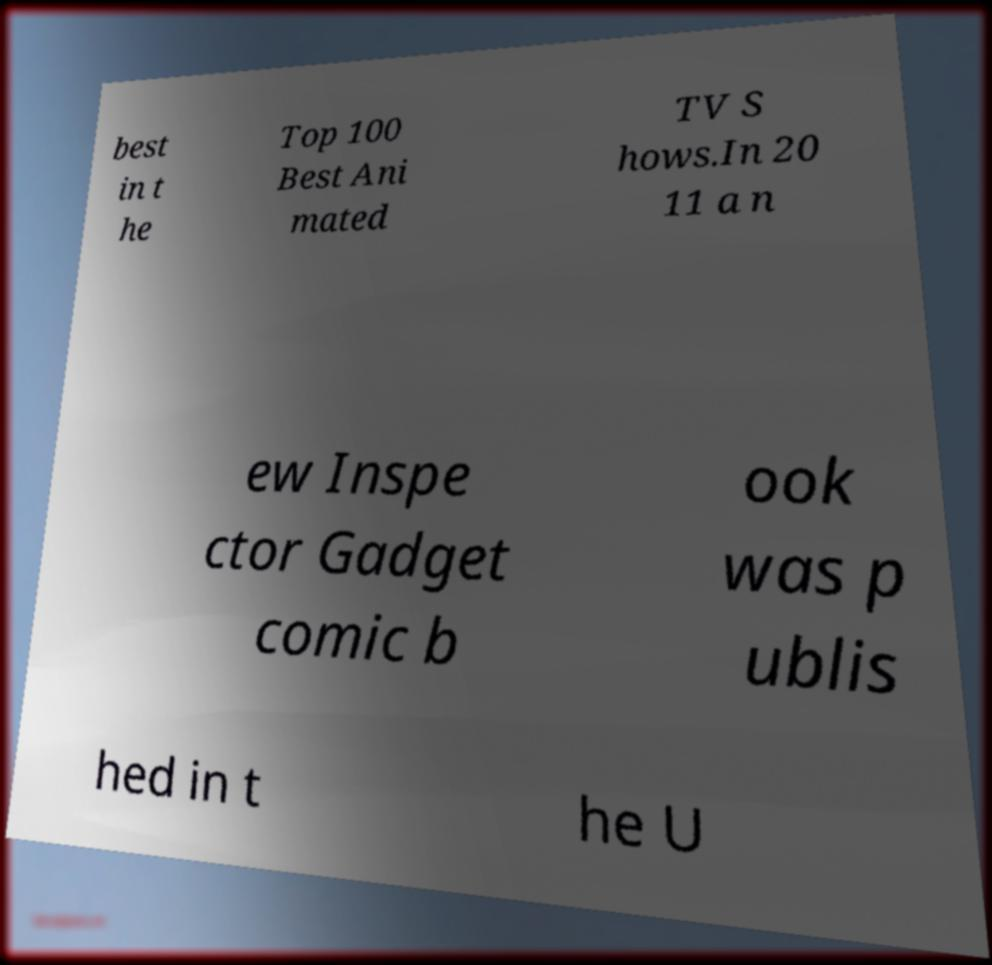Could you extract and type out the text from this image? best in t he Top 100 Best Ani mated TV S hows.In 20 11 a n ew Inspe ctor Gadget comic b ook was p ublis hed in t he U 